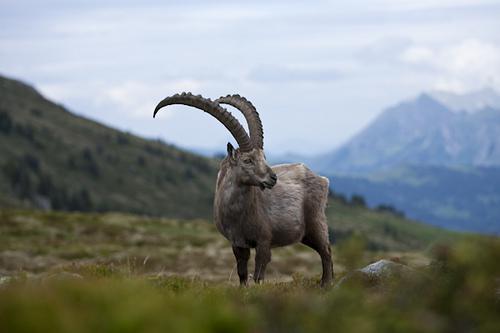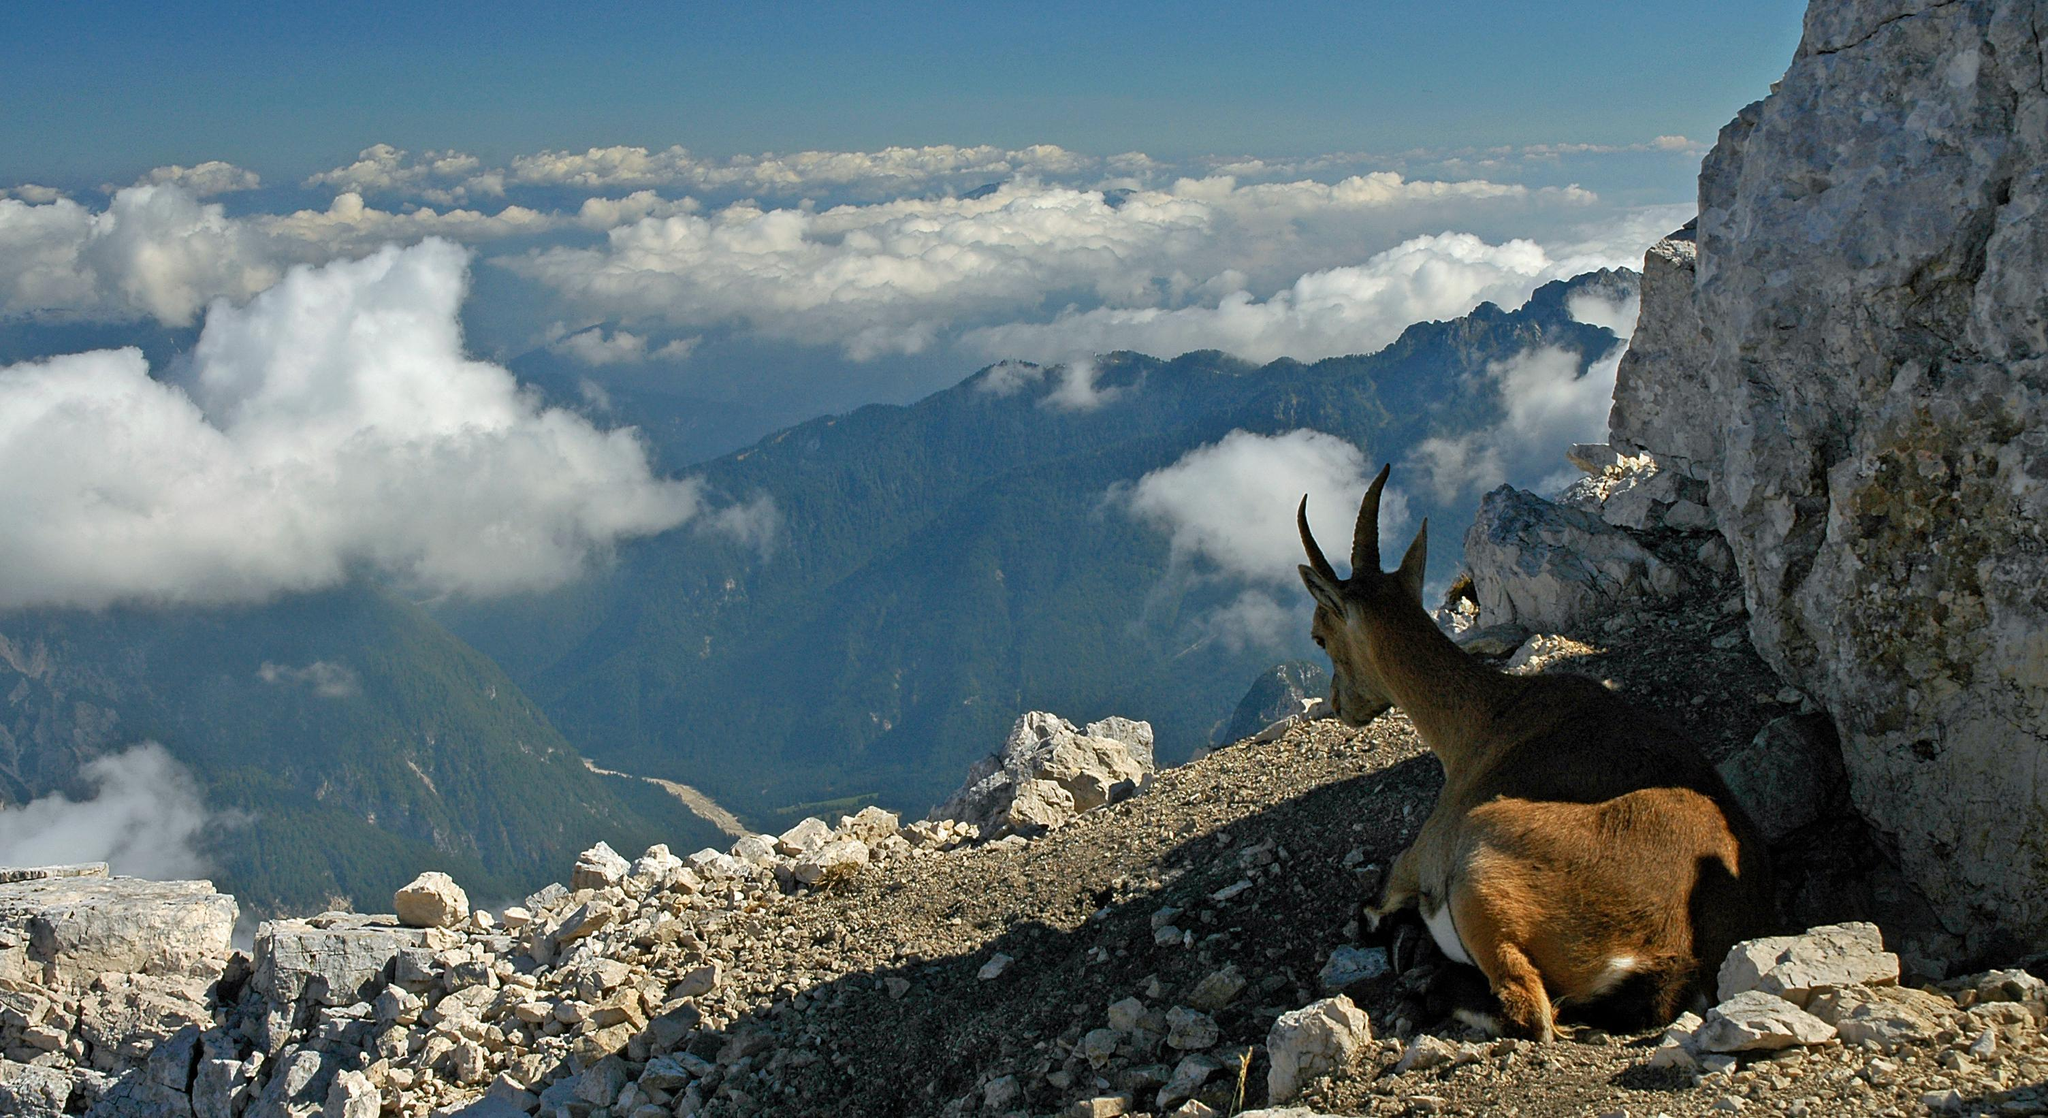The first image is the image on the left, the second image is the image on the right. Analyze the images presented: Is the assertion "A horned animal has both front legs off the ground in one image." valid? Answer yes or no. No. The first image is the image on the left, the second image is the image on the right. Given the left and right images, does the statement "The animal in the image on the right is sitting and resting." hold true? Answer yes or no. Yes. 